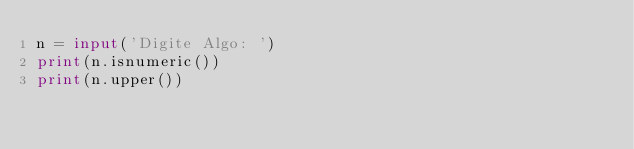<code> <loc_0><loc_0><loc_500><loc_500><_Python_>n = input('Digite Algo: ')
print(n.isnumeric())
print(n.upper())</code> 